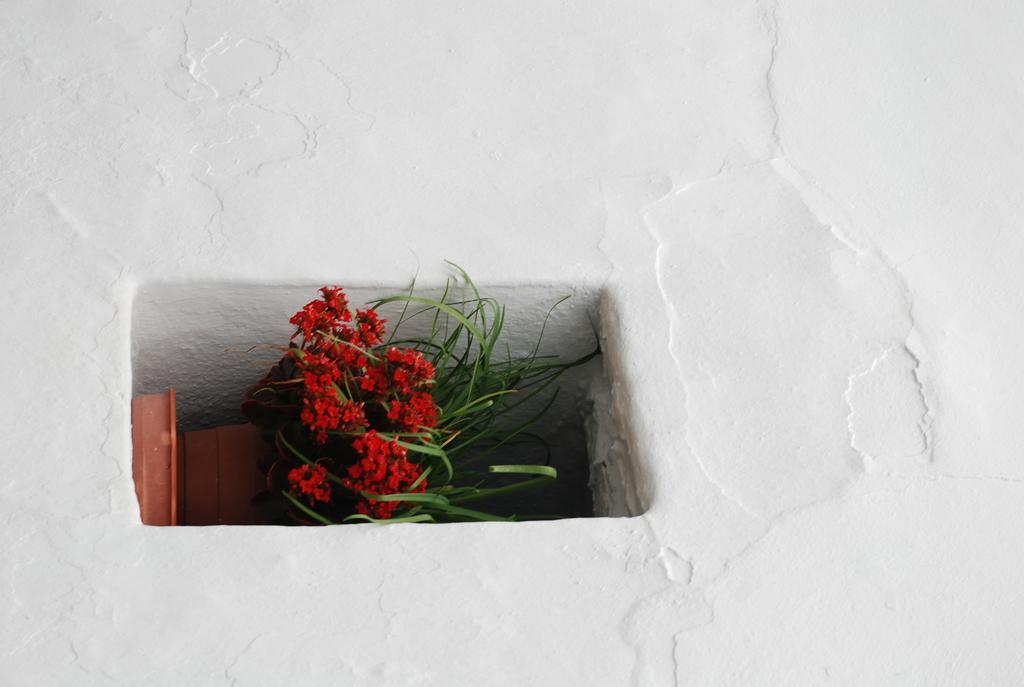Please provide a concise description of this image. In this image I can see a house plant along with the red color flowers which is placed inside the wall. 